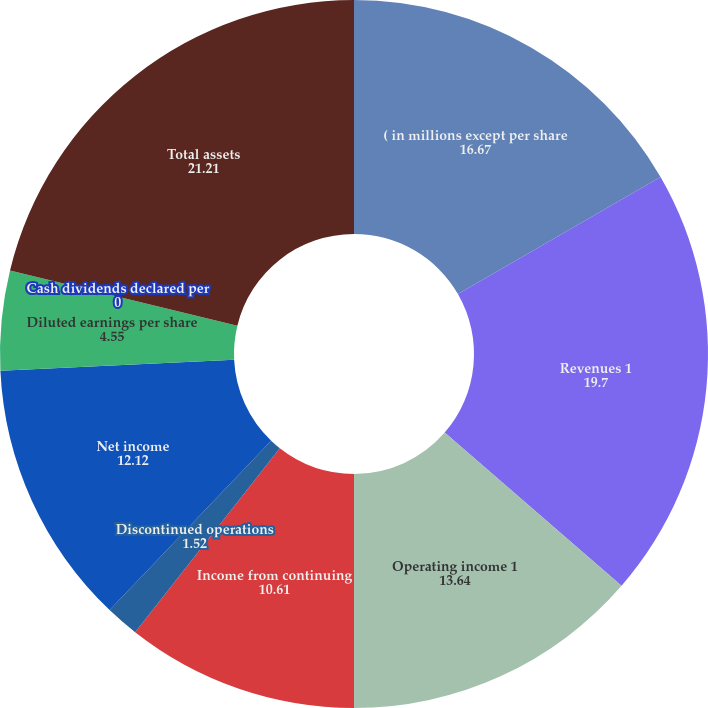Convert chart. <chart><loc_0><loc_0><loc_500><loc_500><pie_chart><fcel>( in millions except per share<fcel>Revenues 1<fcel>Operating income 1<fcel>Income from continuing<fcel>Discontinued operations<fcel>Net income<fcel>Diluted earnings per share<fcel>Cash dividends declared per<fcel>Total assets<nl><fcel>16.67%<fcel>19.7%<fcel>13.64%<fcel>10.61%<fcel>1.52%<fcel>12.12%<fcel>4.55%<fcel>0.0%<fcel>21.21%<nl></chart> 